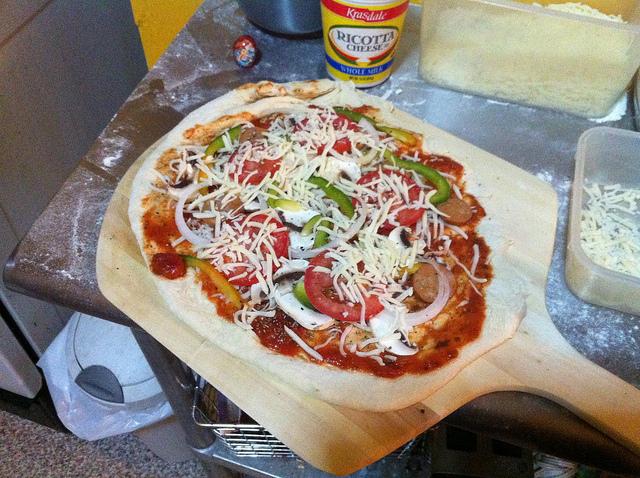What type of food is this?
Give a very brief answer. Pizza. What is the yellow and red container in the background used for?
Short answer required. Ricotta cheese. Is this a buffet?
Keep it brief. No. Is there any broccoli on the pizza?
Give a very brief answer. No. Is this a donut factory?
Write a very short answer. No. Is it on a cooking stone?
Short answer required. No. What is the person has to protect from the hot surface?
Quick response, please. Table. What we eat the pizza right now?
Write a very short answer. No. Do you see a spatula?
Answer briefly. No. Is this pizza New York or Chicago style?
Quick response, please. Chicago. 